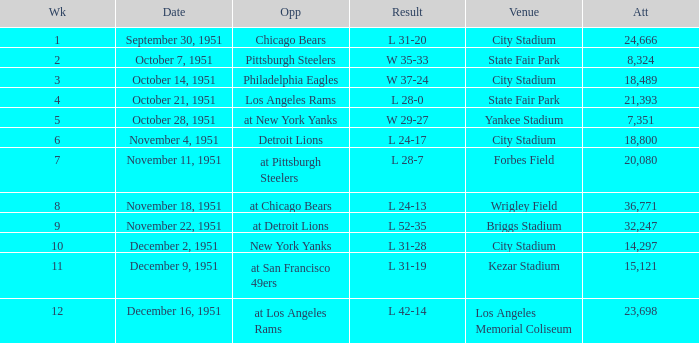Which date's week was more than 4 with the venue being City Stadium and where the attendance was more than 14,297? November 4, 1951. 